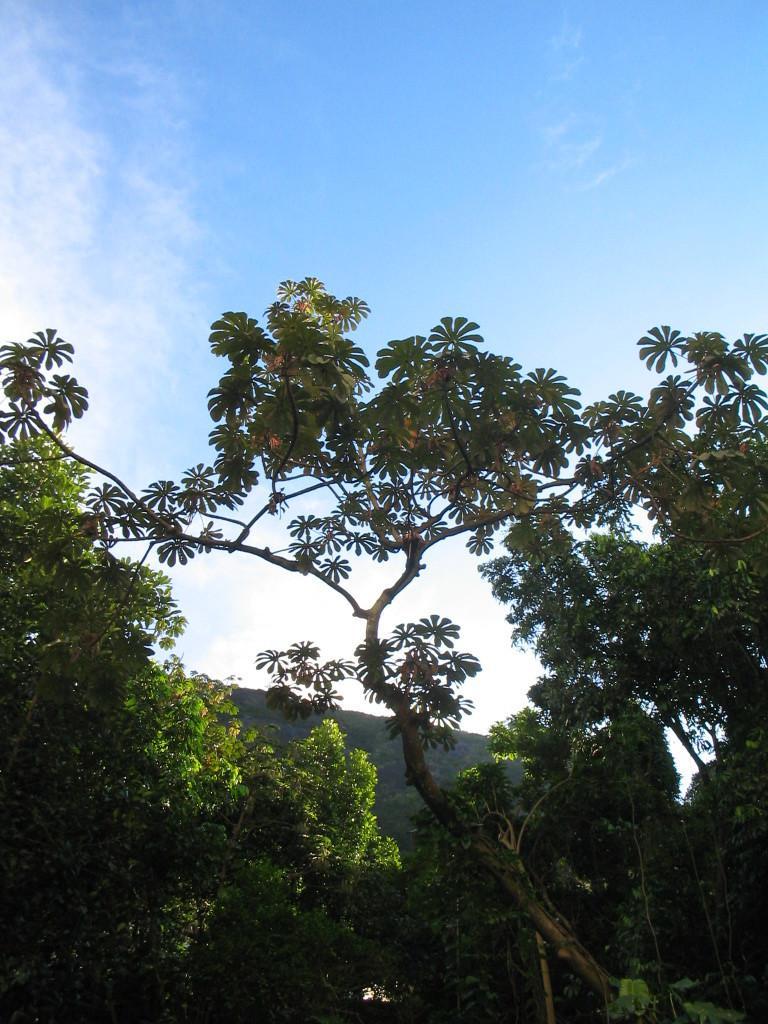Please provide a concise description of this image. In this picture I can see there are few trees, in the backdrop there is a mountain and the sky is clear. 